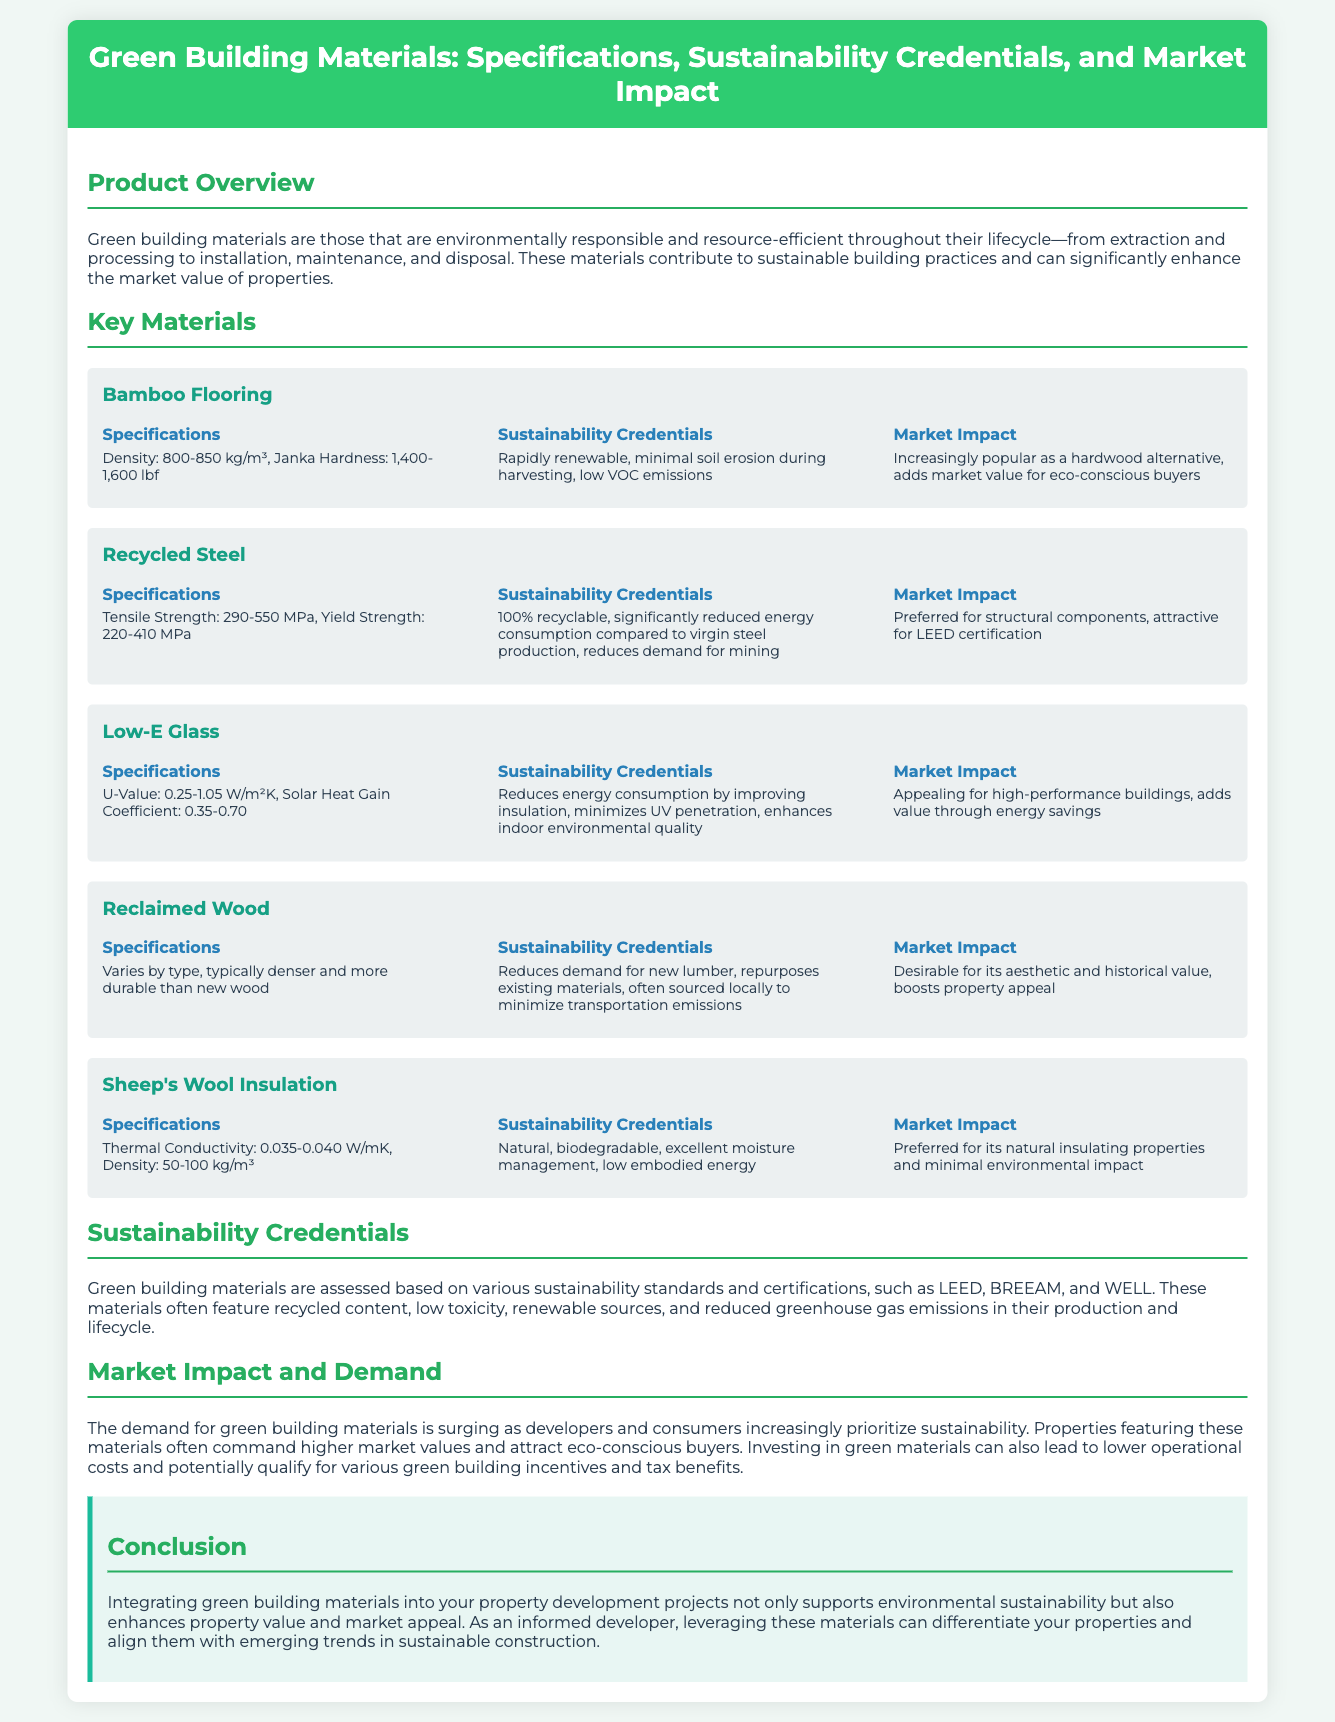what is the density range of bamboo flooring? The density range for bamboo flooring is specified in the document as 800-850 kg/m³.
Answer: 800-850 kg/m³ what is one of the sustainability credentials of recycled steel? The document states that one sustainability credential of recycled steel is that it is 100% recyclable.
Answer: 100% recyclable what is the U-value range for Low-E glass? The U-value for Low-E glass is given in the document as 0.25-1.05 W/m²K.
Answer: 0.25-1.05 W/m²K which green building material is known for its aesthetic and historical value? The document mentions that reclaimed wood is desirable for its aesthetic and historical value.
Answer: Reclaimed wood how does sheep's wool insulation manage moisture? According to the document, sheep's wool insulation has excellent moisture management as part of its sustainability credentials.
Answer: Excellent moisture management what is the main market impact of green building materials? The document highlights that the main market impact is that properties with these materials command higher market values.
Answer: Higher market values what certifications are mentioned for assessing sustainability? The document refers to LEED, BREEAM, and WELL as sustainability certifications.
Answer: LEED, BREEAM, WELL what is the thermal conductivity range for sheep's wool insulation? The thermal conductivity range for sheep's wool insulation is specified as 0.035-0.040 W/mK.
Answer: 0.035-0.040 W/mK why might developers consider integrating green building materials? The document states that integrating green building materials enhances property value and market appeal.
Answer: Enhances property value and market appeal 